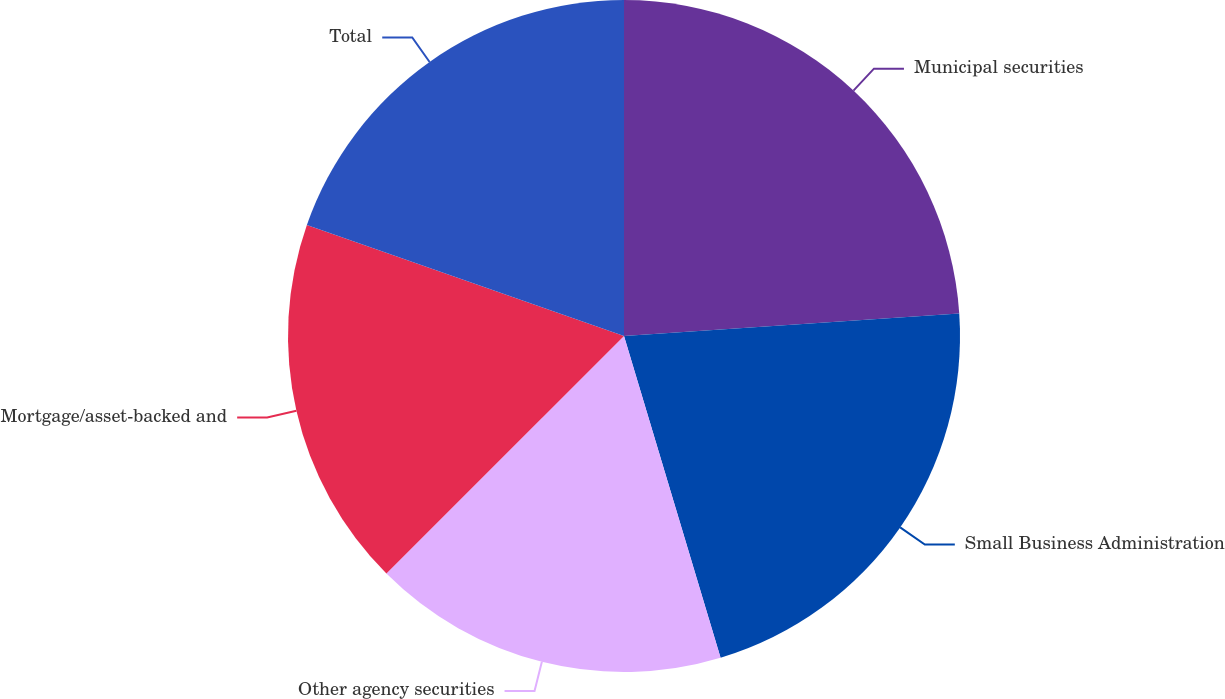<chart> <loc_0><loc_0><loc_500><loc_500><pie_chart><fcel>Municipal securities<fcel>Small Business Administration<fcel>Other agency securities<fcel>Mortgage/asset-backed and<fcel>Total<nl><fcel>23.93%<fcel>21.43%<fcel>17.14%<fcel>17.86%<fcel>19.64%<nl></chart> 